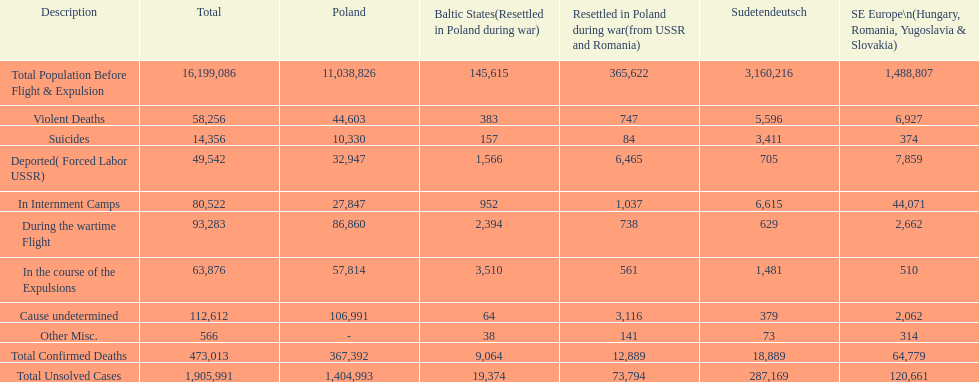What is the overall number of fatalities in detention centers and throughout the wartime escape? 173,805. 